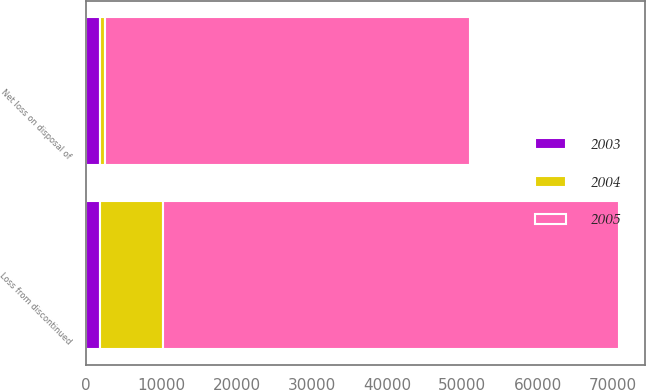<chart> <loc_0><loc_0><loc_500><loc_500><stacked_bar_chart><ecel><fcel>Net loss on disposal of<fcel>Loss from discontinued<nl><fcel>2003<fcel>1935<fcel>1935<nl><fcel>2004<fcel>625<fcel>8345<nl><fcel>2005<fcel>48458<fcel>60475<nl></chart> 